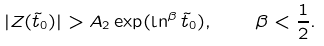Convert formula to latex. <formula><loc_0><loc_0><loc_500><loc_500>| Z ( \tilde { t } _ { 0 } ) | > A _ { 2 } \exp ( \ln ^ { \beta } \tilde { t } _ { 0 } ) , \quad \beta < \frac { 1 } { 2 } .</formula> 